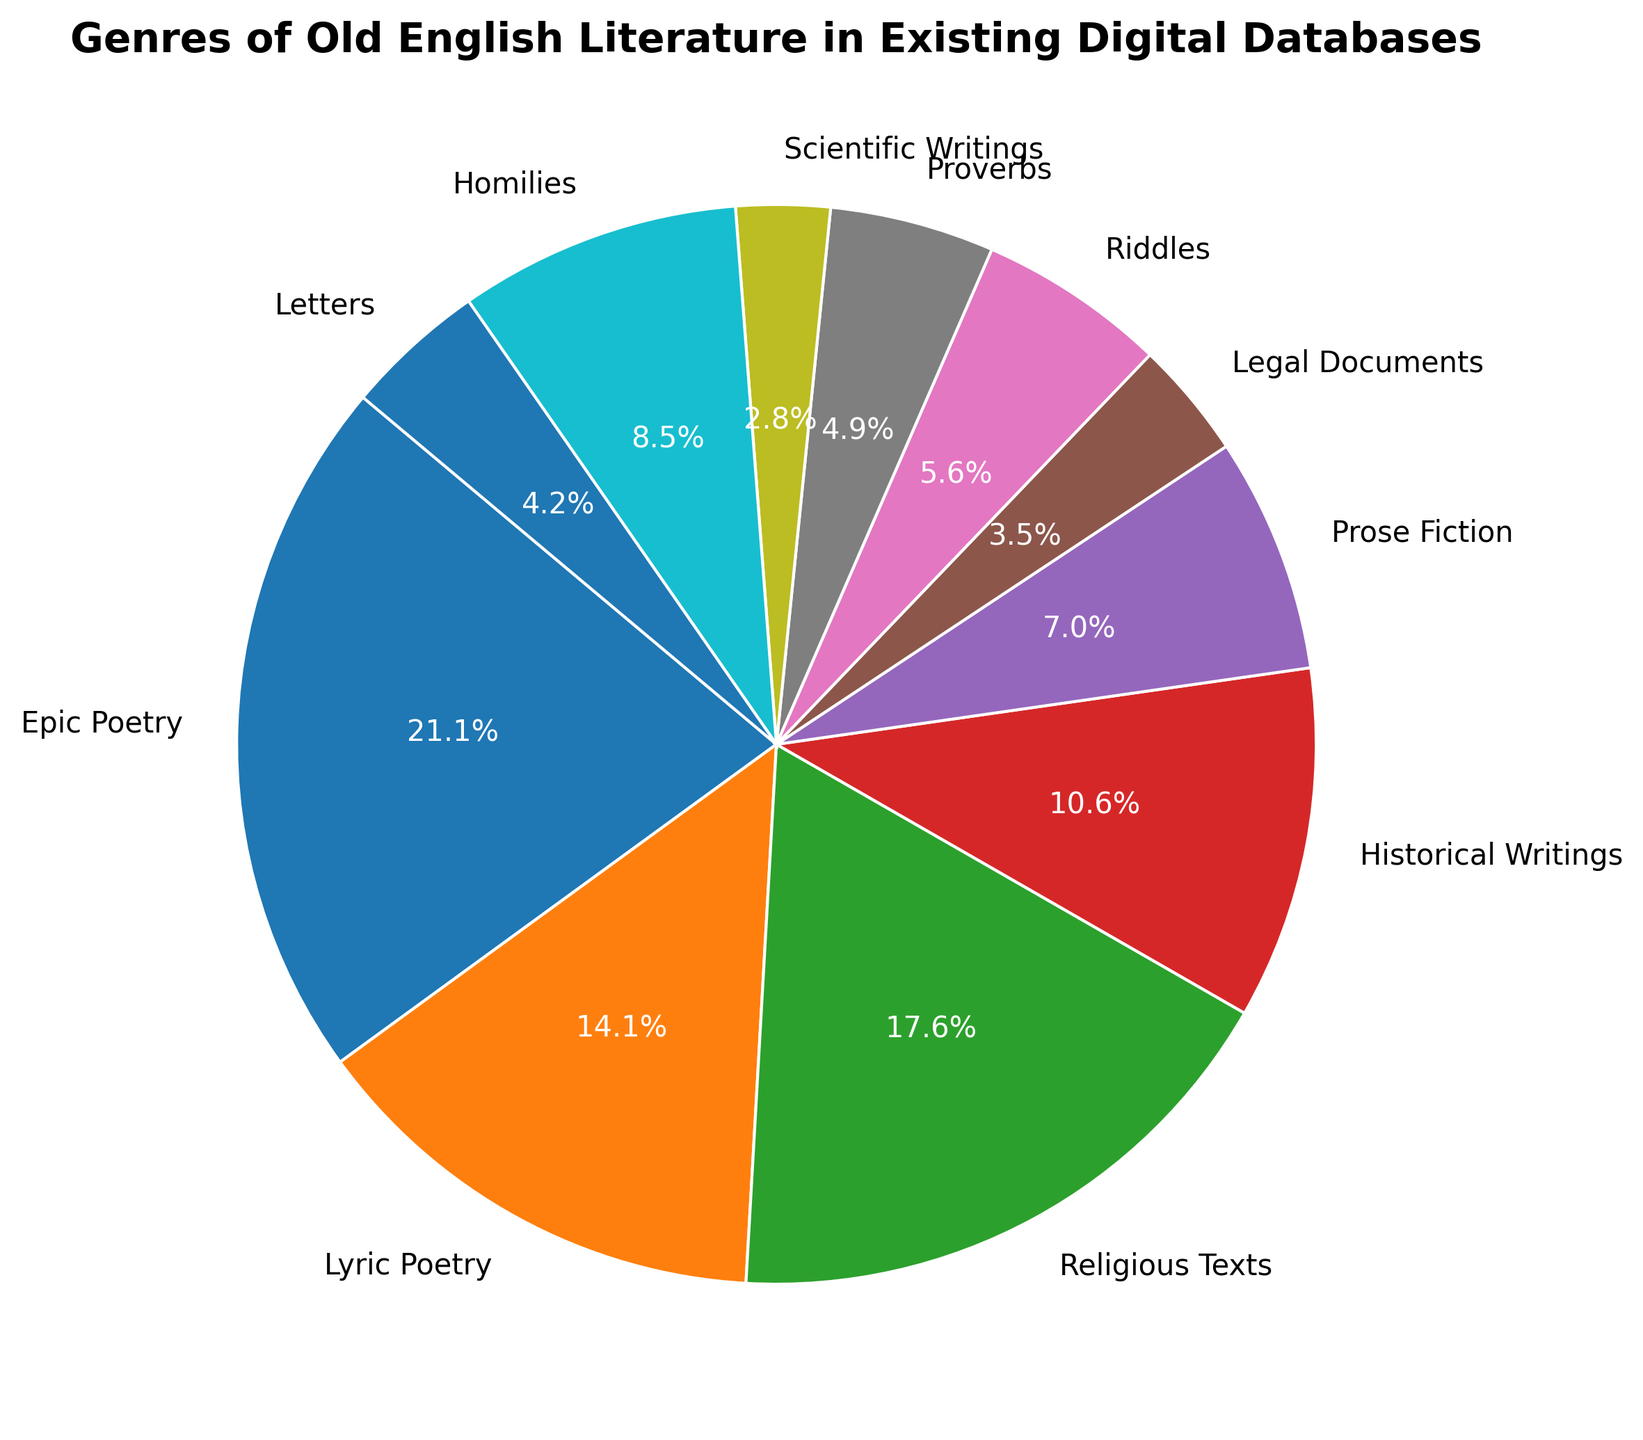What percentage of the genres are accounted for by Epic Poetry and Religious Texts combined? Epic Poetry takes up 30% and Religious Texts take up 25%. Adding these, we get 30% + 25% = 55%.
Answer: 55% How does the proportion of Historical Writings compare to that of Lyric Poetry? Lyric Poetry accounts for 20%, while Historical Writings account for 15%. Since 20% is greater than 15%, Lyric Poetry has a larger proportion.
Answer: Lyric Poetry is greater Which genre has the smallest representation in the pie chart? Scientific Writings has the smallest slice, representing 4%.
Answer: Scientific Writings If you combine the counts of Lyric Poetry, Proverbs, and Letters, what is their total percentage? Lyric Poetry has 20%, Proverbs 7%, and Letters 6%. Summing these, we get 20% + 7% + 6% = 33%.
Answer: 33% How many more genres have percentages less than 10% compared to those with 10% or more? Genres under 10%: Legal Documents, Riddles, Proverbs, Scientific Writings, Homilies, and Letters (6 genres). Genres with 10% or more: Epic Poetry, Lyric Poetry, Religious Texts, Historical Writings, and Prose Fiction (5 genres). The difference is 6 - 5 = 1.
Answer: 1 more Which genre is visually nearest to Prose Fiction in representation? Homilies, with its 12%, is visually closest to Prose Fiction, which has 10%.
Answer: Homilies Does any genre account for exactly one-fourth (25%) of the representation in the pie chart? Yes, Religious Texts account for exactly 25% of the representation.
Answer: Religious Texts What is the difference in representation between Epic Poetry and Prose Fiction? Epic Poetry represents 30%, and Prose Fiction represents 10%. The difference is 30% - 10% = 20%.
Answer: 20% Comparing Riddles and Homilies, which is represented more, and by how much? Riddles account for 8% while Homilies account for 12%. The difference is 12% - 8% = 4%. Homilies are represented more by 4%.
Answer: Homilies by 4% 